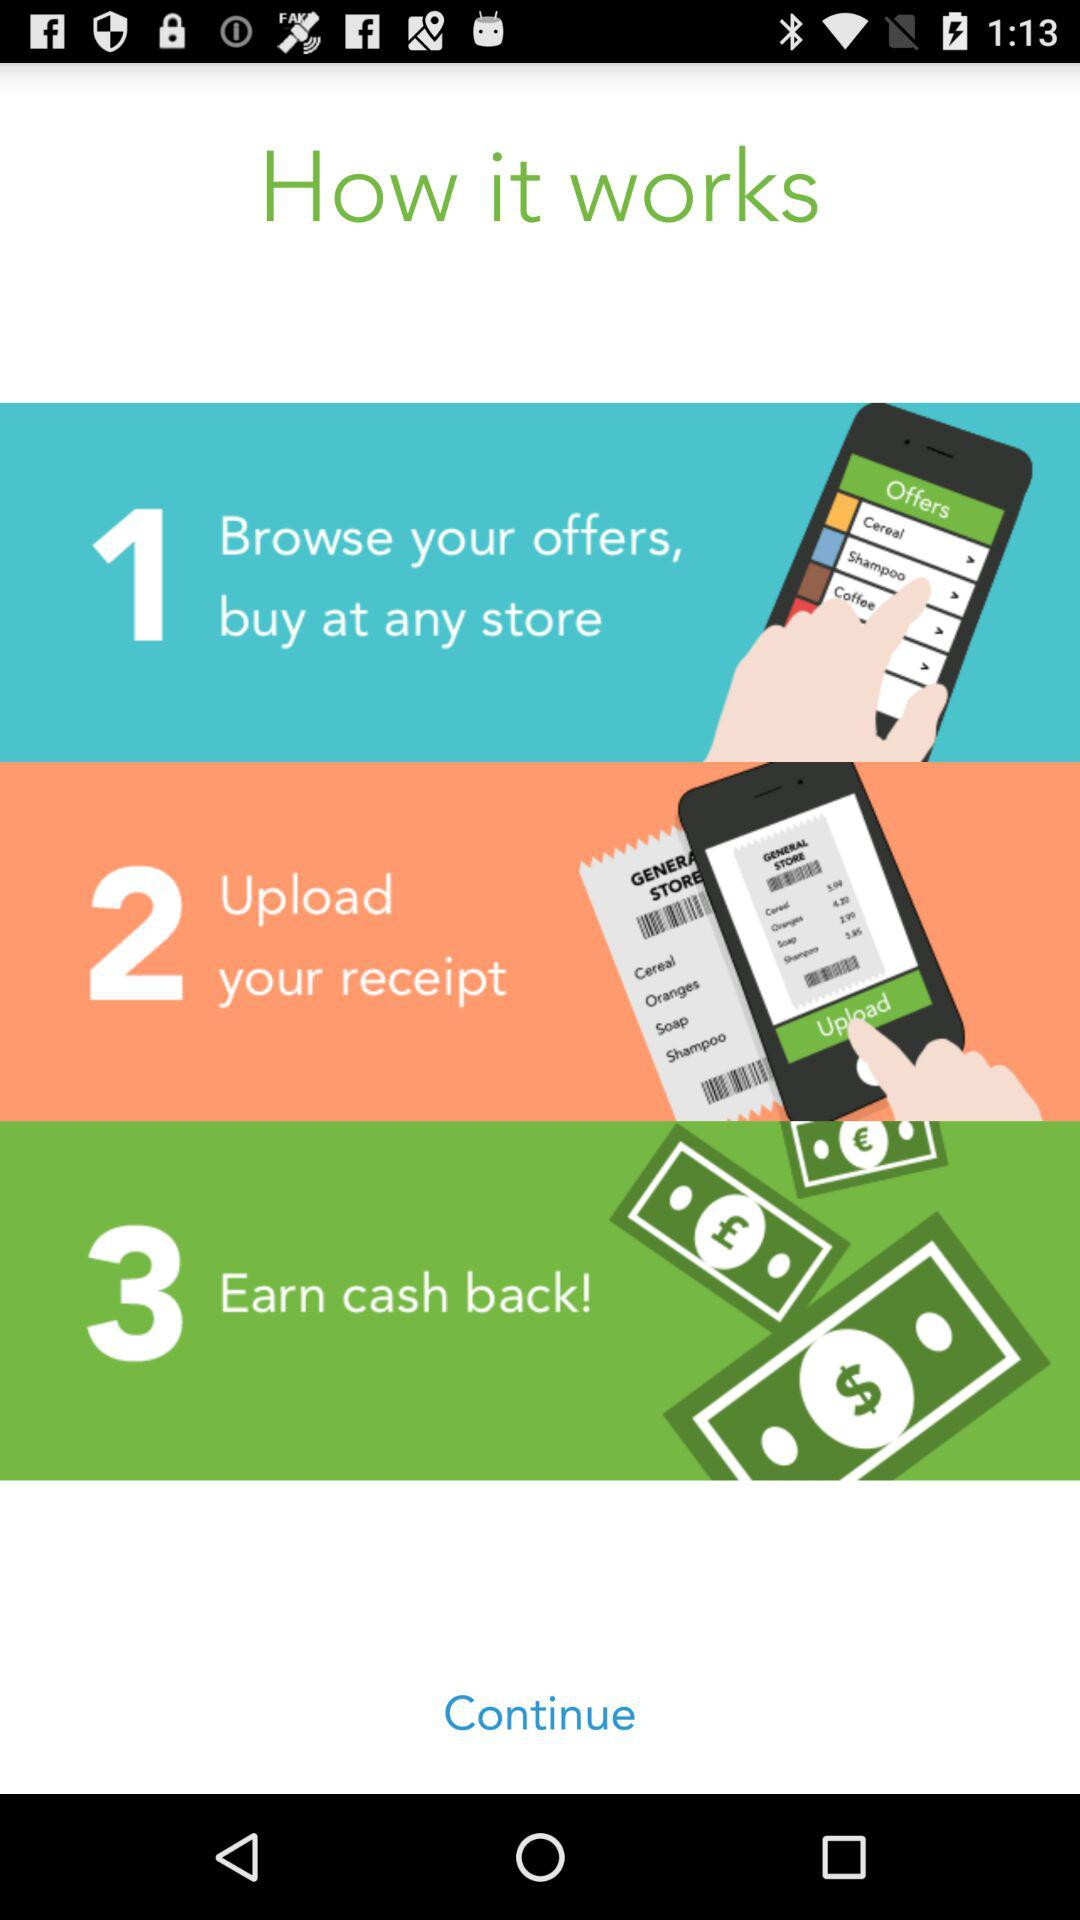What is the first step? The first step is "Browse your offers, buy at any store". 